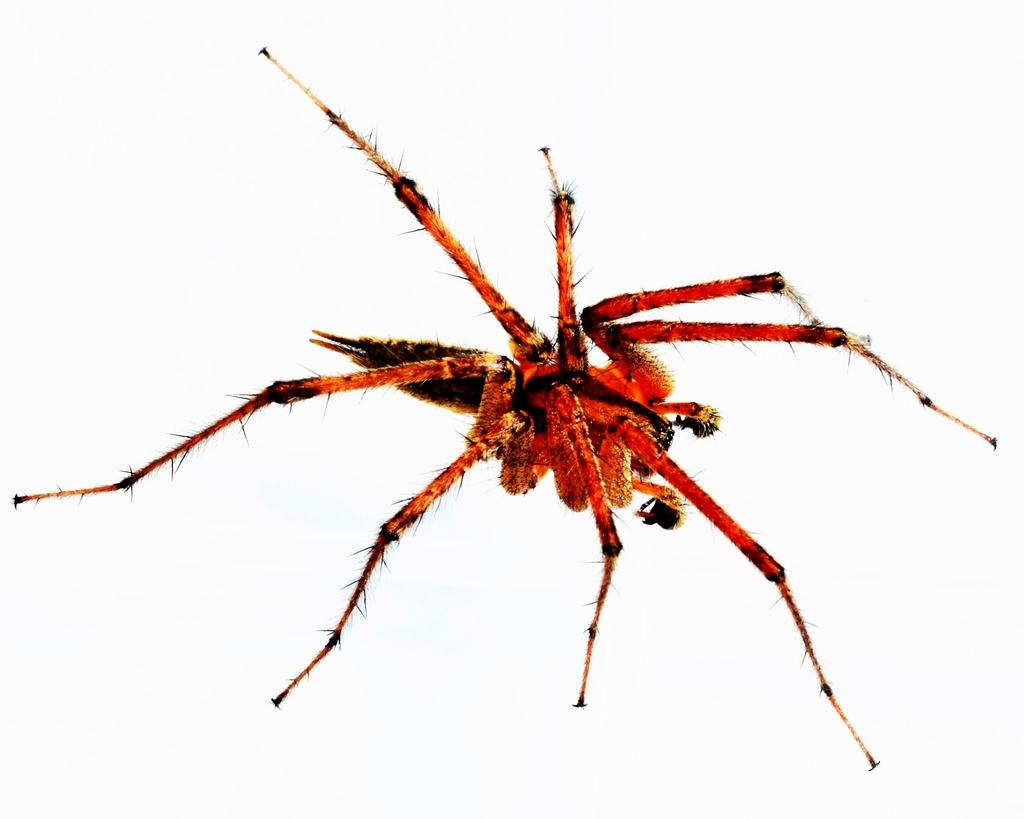What is the main subject of the image? There is a spider in the image. What type of activity is taking place at the airport in the image? There is no airport or activity present in the image; it only features a spider. 